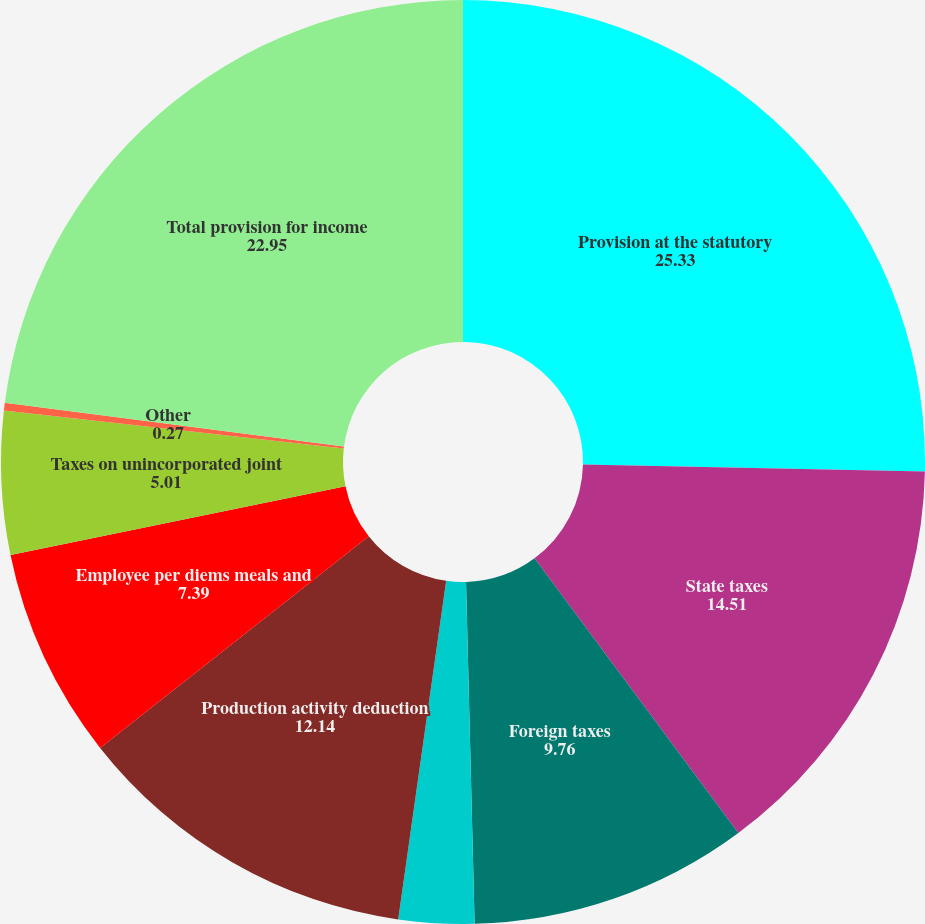Convert chart. <chart><loc_0><loc_0><loc_500><loc_500><pie_chart><fcel>Provision at the statutory<fcel>State taxes<fcel>Foreign taxes<fcel>Contingency reserves net<fcel>Production activity deduction<fcel>Employee per diems meals and<fcel>Taxes on unincorporated joint<fcel>Other<fcel>Total provision for income<nl><fcel>25.33%<fcel>14.51%<fcel>9.76%<fcel>2.64%<fcel>12.14%<fcel>7.39%<fcel>5.01%<fcel>0.27%<fcel>22.95%<nl></chart> 